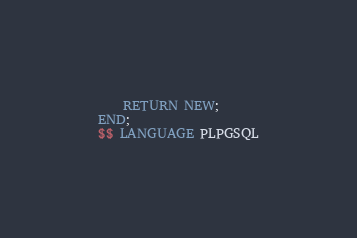Convert code to text. <code><loc_0><loc_0><loc_500><loc_500><_SQL_>	RETURN NEW;
END;
$$ LANGUAGE PLPGSQL</code> 